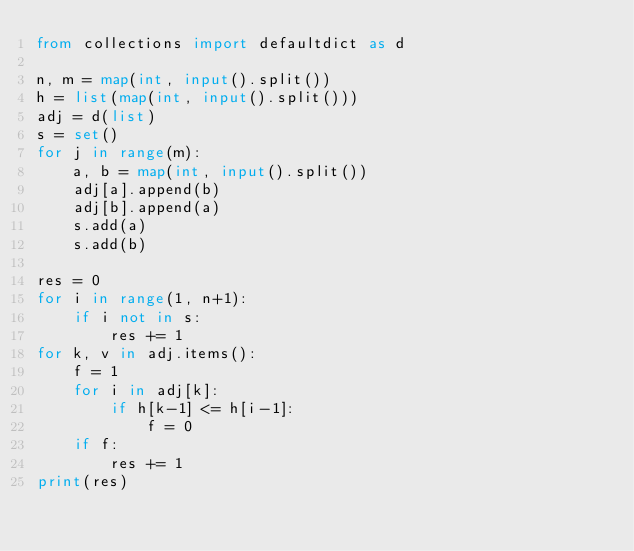<code> <loc_0><loc_0><loc_500><loc_500><_Python_>from collections import defaultdict as d

n, m = map(int, input().split())
h = list(map(int, input().split()))
adj = d(list)
s = set()
for j in range(m):
	a, b = map(int, input().split())
	adj[a].append(b)
	adj[b].append(a)
	s.add(a)
	s.add(b)

res = 0
for i in range(1, n+1):
	if i not in s:
		res += 1
for k, v in adj.items():
	f = 1
	for i in adj[k]:
		if h[k-1] <= h[i-1]:
			f = 0
	if f:
		res += 1
print(res)</code> 